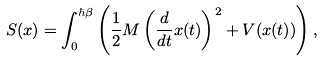<formula> <loc_0><loc_0><loc_500><loc_500>S ( x ) = \int _ { 0 } ^ { \hbar { \beta } } \left ( { \frac { 1 } { 2 } } M \left ( { \frac { d } { d t } } x ( t ) \right ) ^ { 2 } + V ( x ( t ) ) \right ) ,</formula> 